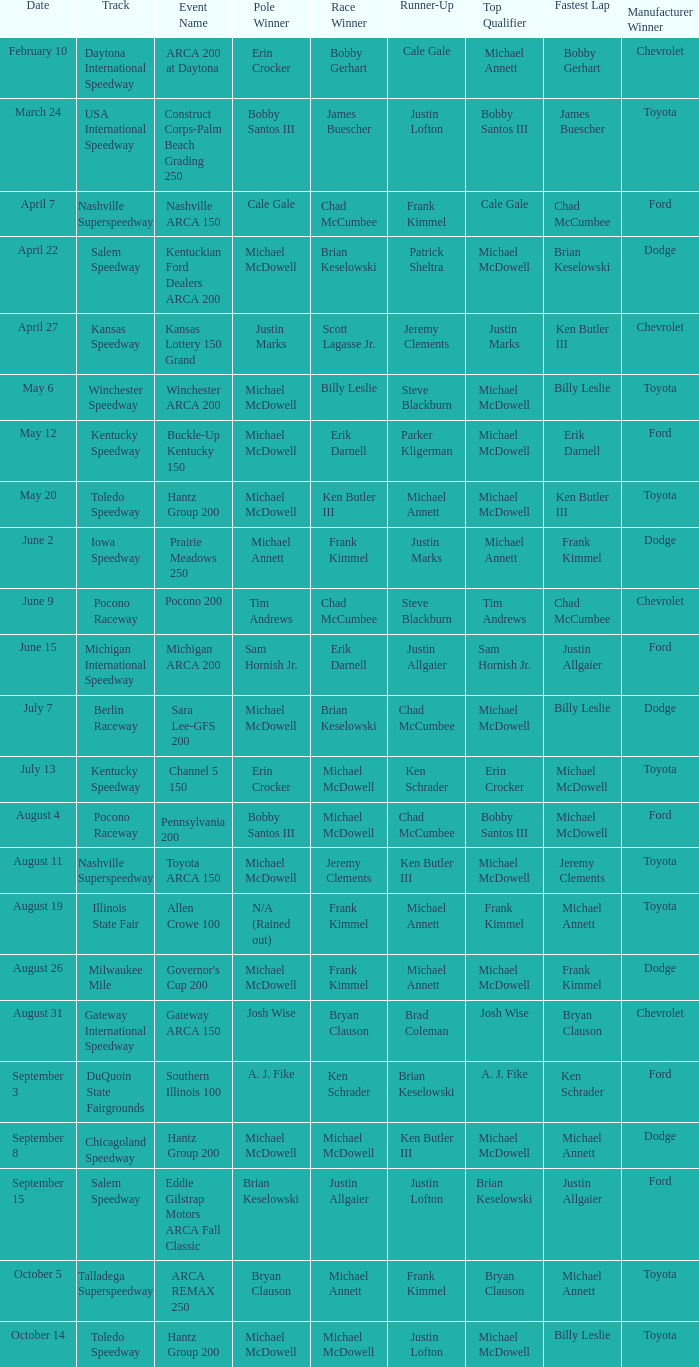Tell me the track for scott lagasse jr. Kansas Speedway. 